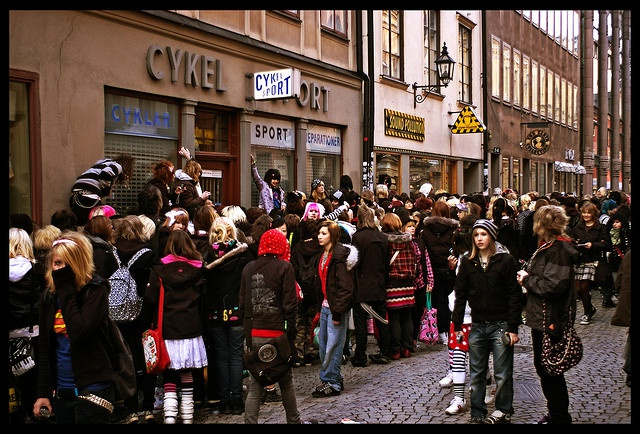Describe the objects in this image and their specific colors. I can see people in black, maroon, gray, and white tones, people in black, maroon, and brown tones, people in black, gray, maroon, and lightgray tones, people in black, lavender, maroon, and brown tones, and people in black, maroon, red, and gray tones in this image. 